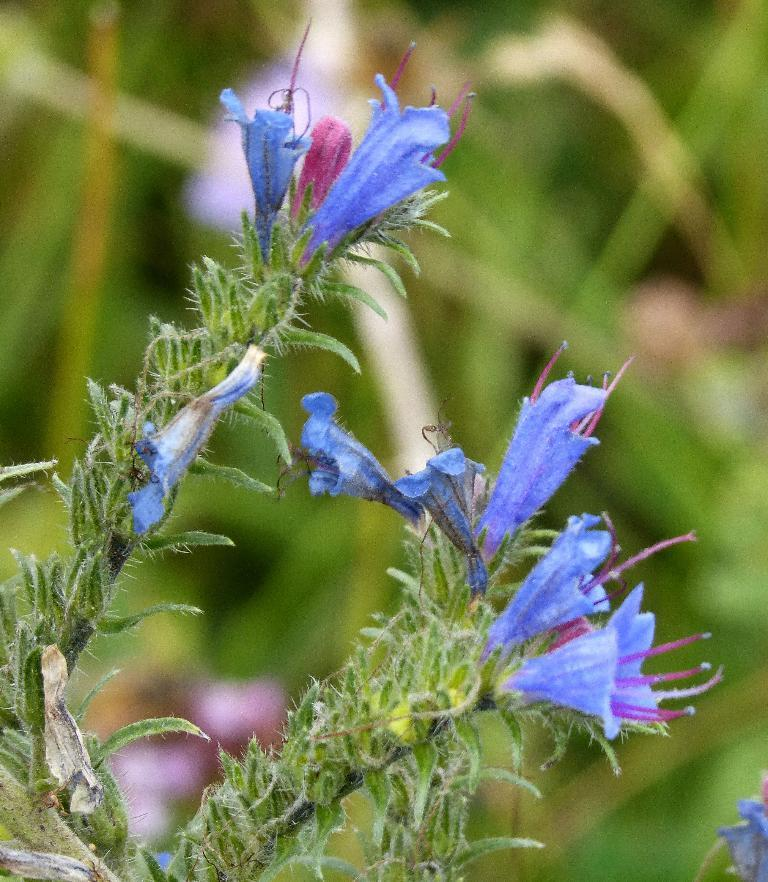What type of plants can be seen in the image? There are flower plants in the image. What color are the flowers on the plants? The flowers are blue in color. Can you describe the background of the image? The background of the image is blurred. What type of representative is present in the image? There is no representative present in the image; it features flower plants with blue flowers and a blurred background. Can you see any deer in the image? There are no deer present in the image. 